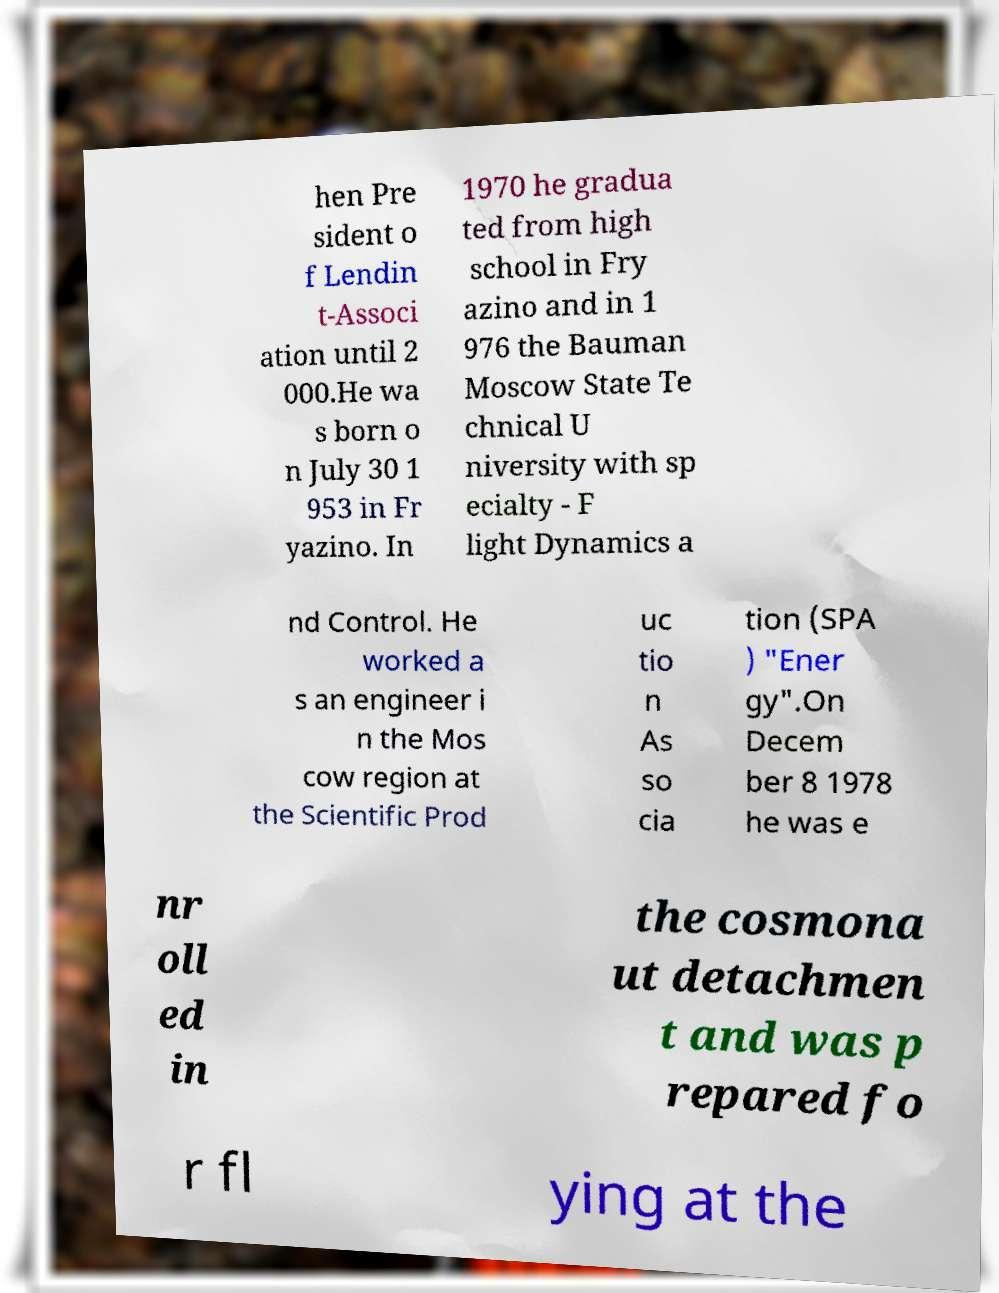Please read and relay the text visible in this image. What does it say? hen Pre sident o f Lendin t-Associ ation until 2 000.He wa s born o n July 30 1 953 in Fr yazino. In 1970 he gradua ted from high school in Fry azino and in 1 976 the Bauman Moscow State Te chnical U niversity with sp ecialty - F light Dynamics a nd Control. He worked a s an engineer i n the Mos cow region at the Scientific Prod uc tio n As so cia tion (SPA ) "Ener gy".On Decem ber 8 1978 he was e nr oll ed in the cosmona ut detachmen t and was p repared fo r fl ying at the 